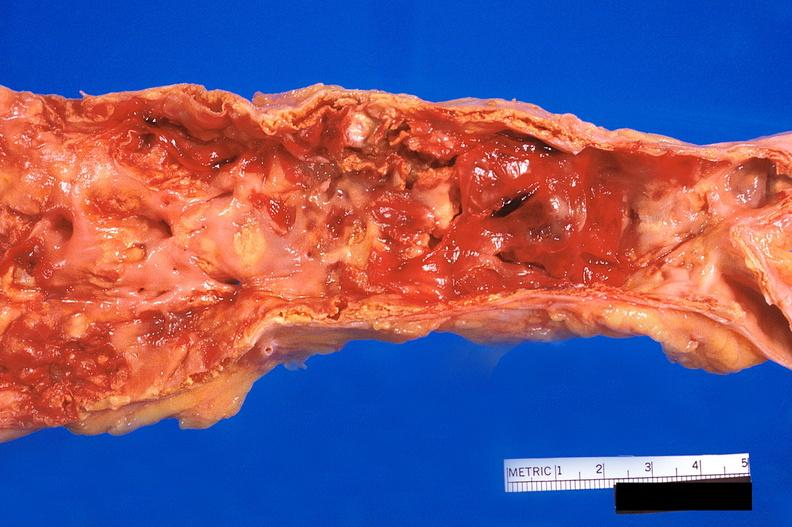what does this image show?
Answer the question using a single word or phrase. Abdominal aorta 